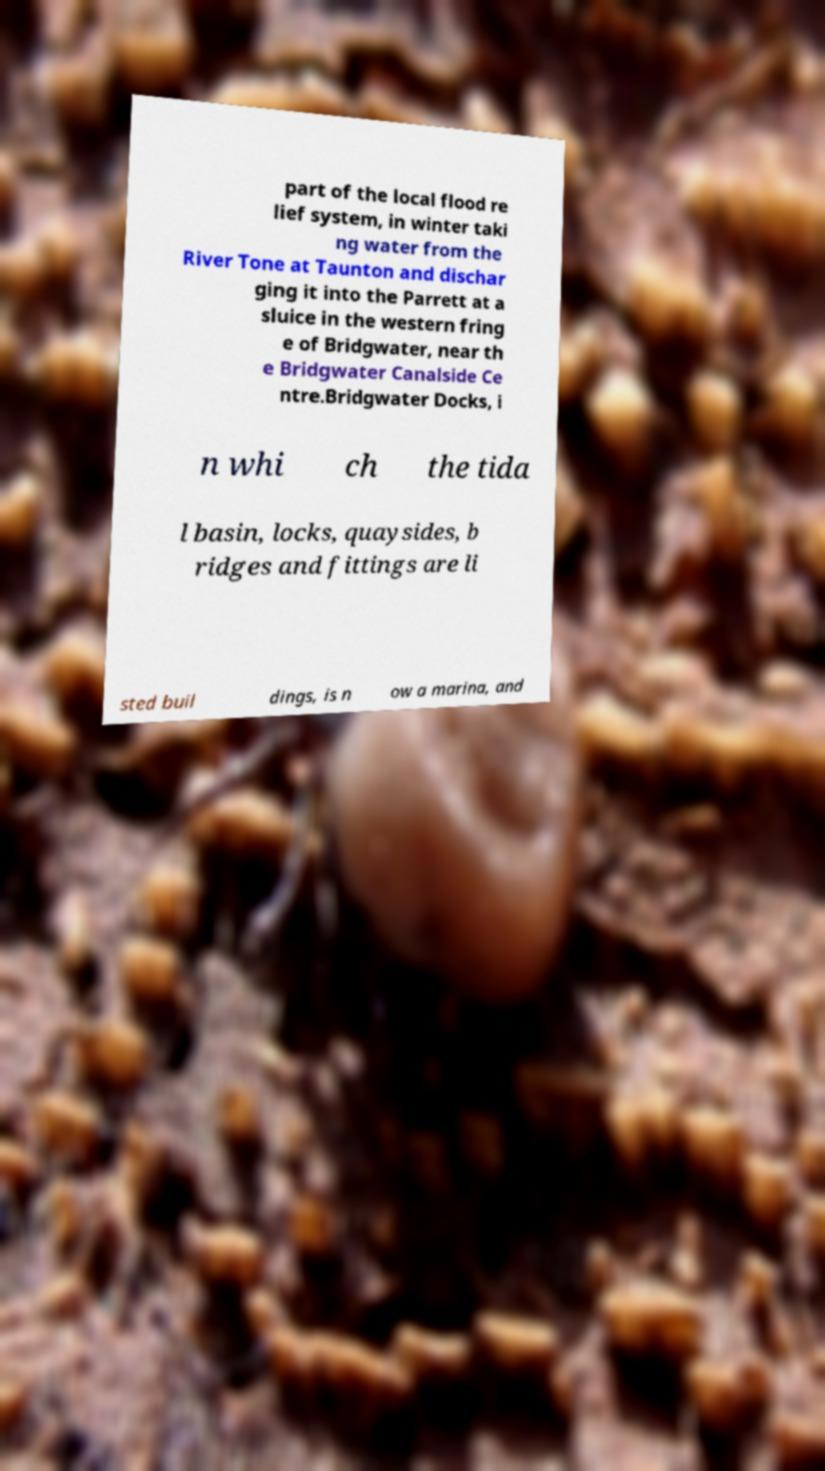Please read and relay the text visible in this image. What does it say? part of the local flood re lief system, in winter taki ng water from the River Tone at Taunton and dischar ging it into the Parrett at a sluice in the western fring e of Bridgwater, near th e Bridgwater Canalside Ce ntre.Bridgwater Docks, i n whi ch the tida l basin, locks, quaysides, b ridges and fittings are li sted buil dings, is n ow a marina, and 